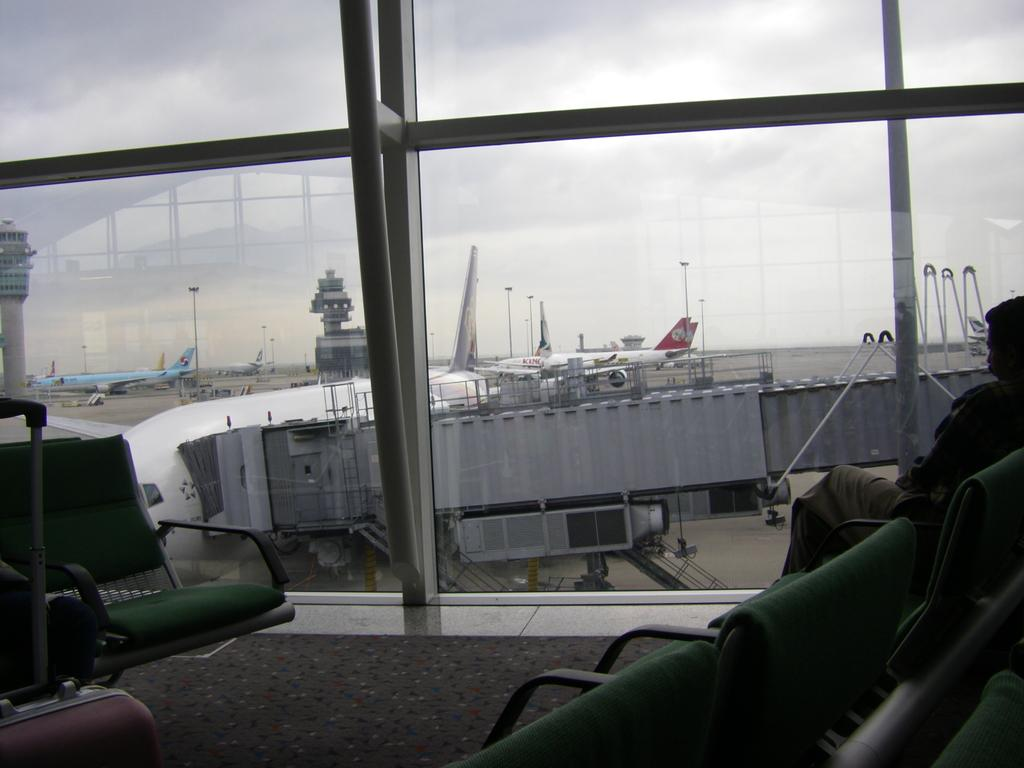What is the vantage point of the image? The image is taken from behind a window. What type of furniture is present in the image? There are many chairs in the image. What can be seen on the left side of the image? There is a luggage bag on the left side of the image. What type of vehicles are visible in the image? There are airplanes visible in the image. What else can be seen in the image besides the chairs and airplanes? There are other compartments visible in the image. What is the governor doing in the image? There is no governor present in the image. What type of work is being performed in the image? The image does not depict any specific work being performed. 